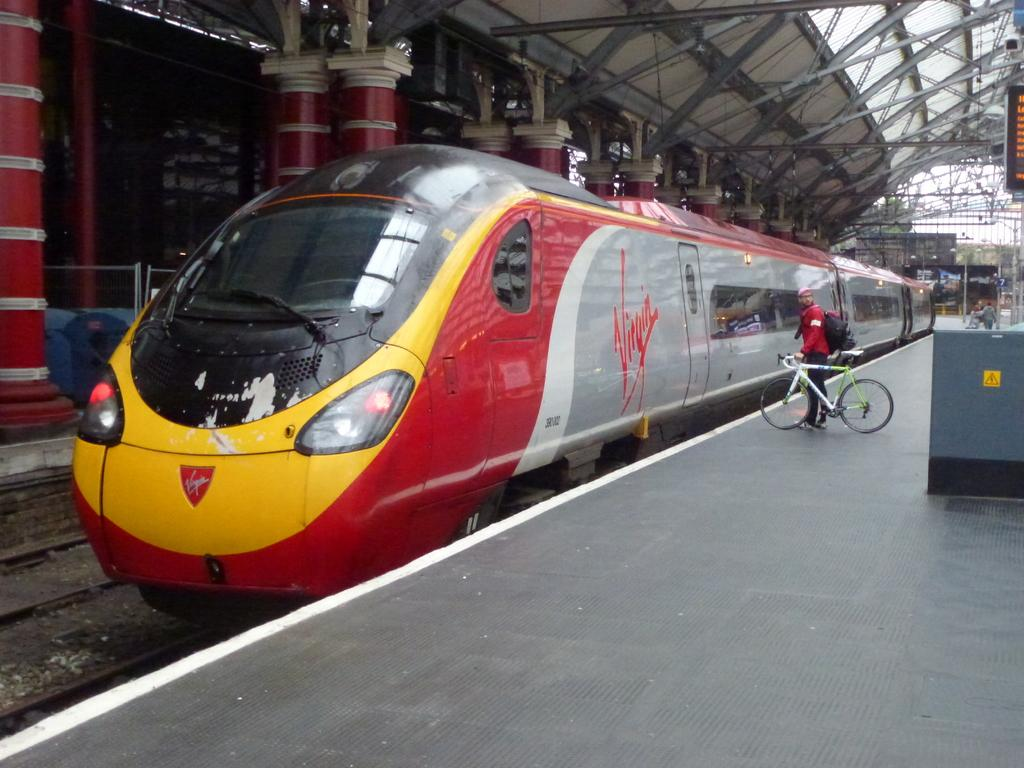<image>
Describe the image concisely. a red, yellow and gray train with the logo for virgin wireless on its side. 